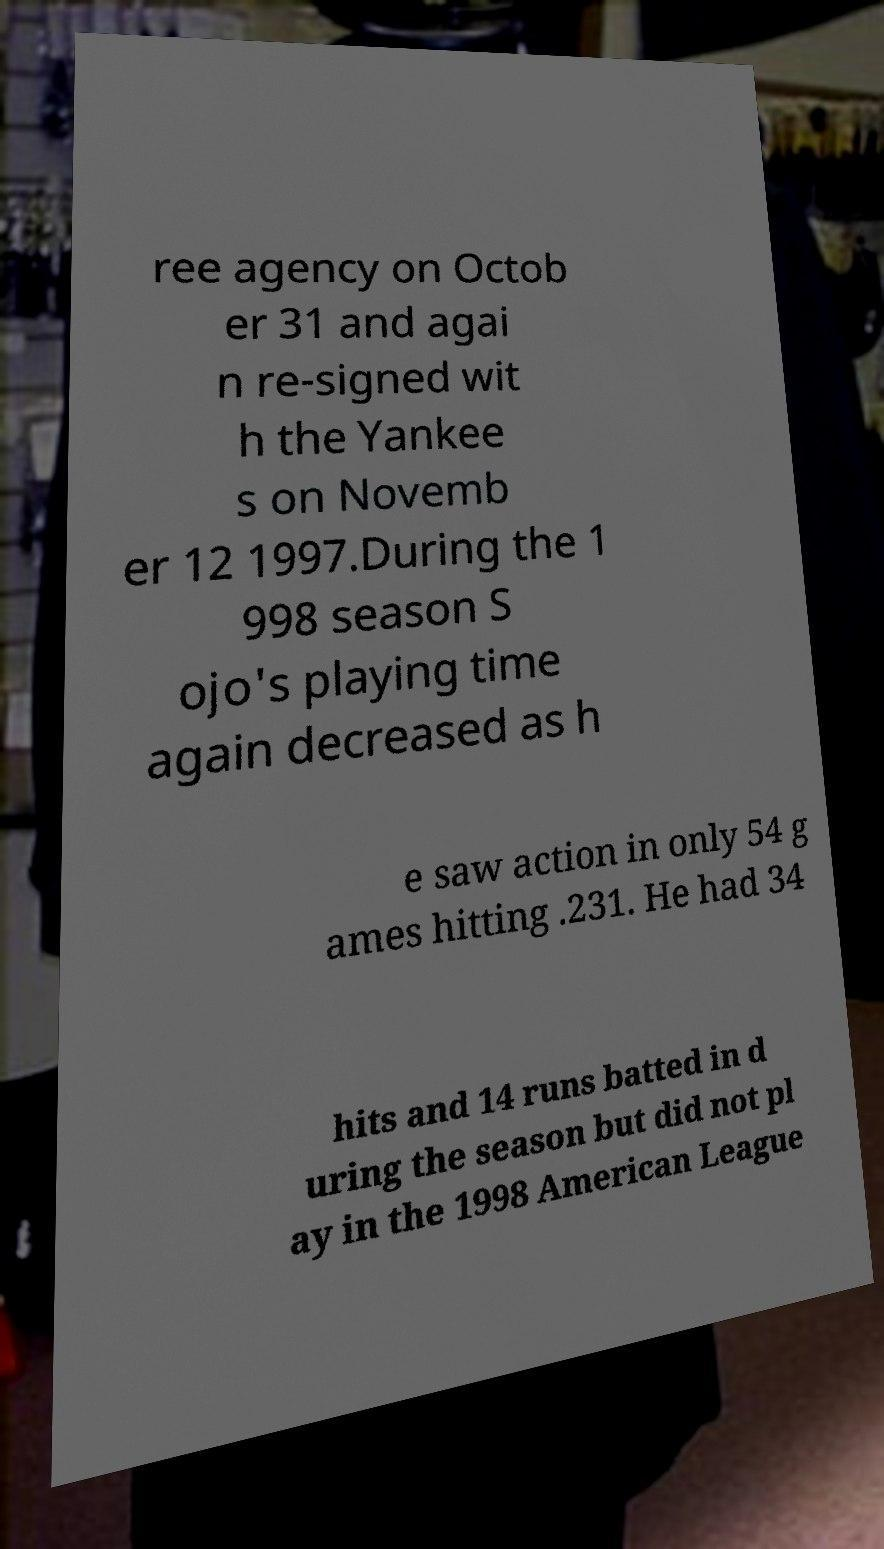Could you extract and type out the text from this image? ree agency on Octob er 31 and agai n re-signed wit h the Yankee s on Novemb er 12 1997.During the 1 998 season S ojo's playing time again decreased as h e saw action in only 54 g ames hitting .231. He had 34 hits and 14 runs batted in d uring the season but did not pl ay in the 1998 American League 